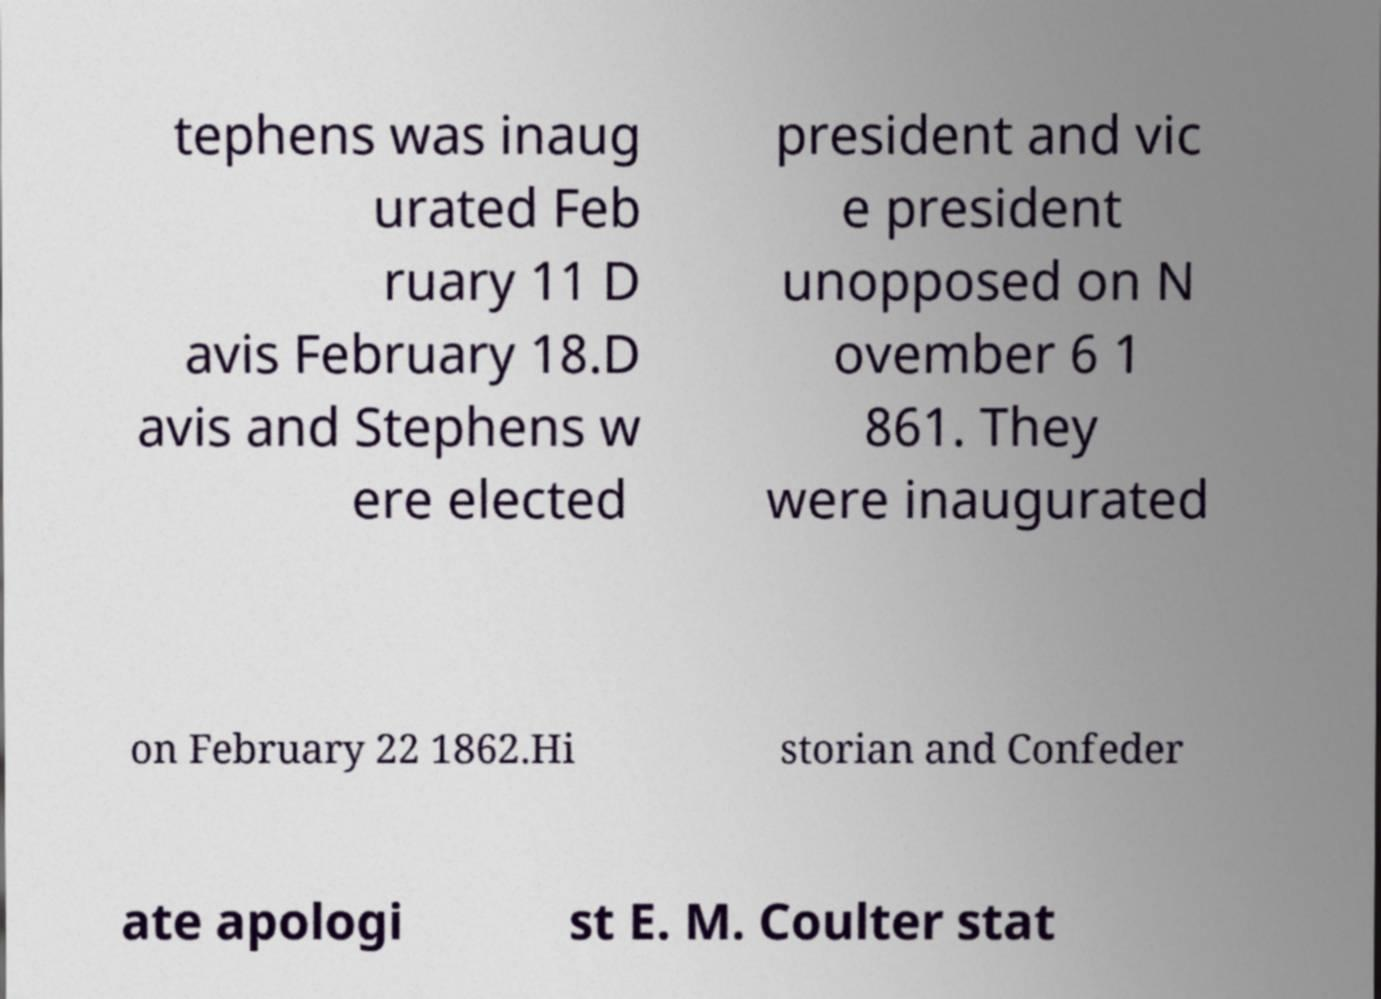For documentation purposes, I need the text within this image transcribed. Could you provide that? tephens was inaug urated Feb ruary 11 D avis February 18.D avis and Stephens w ere elected president and vic e president unopposed on N ovember 6 1 861. They were inaugurated on February 22 1862.Hi storian and Confeder ate apologi st E. M. Coulter stat 